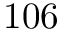Convert formula to latex. <formula><loc_0><loc_0><loc_500><loc_500>1 0 6</formula> 